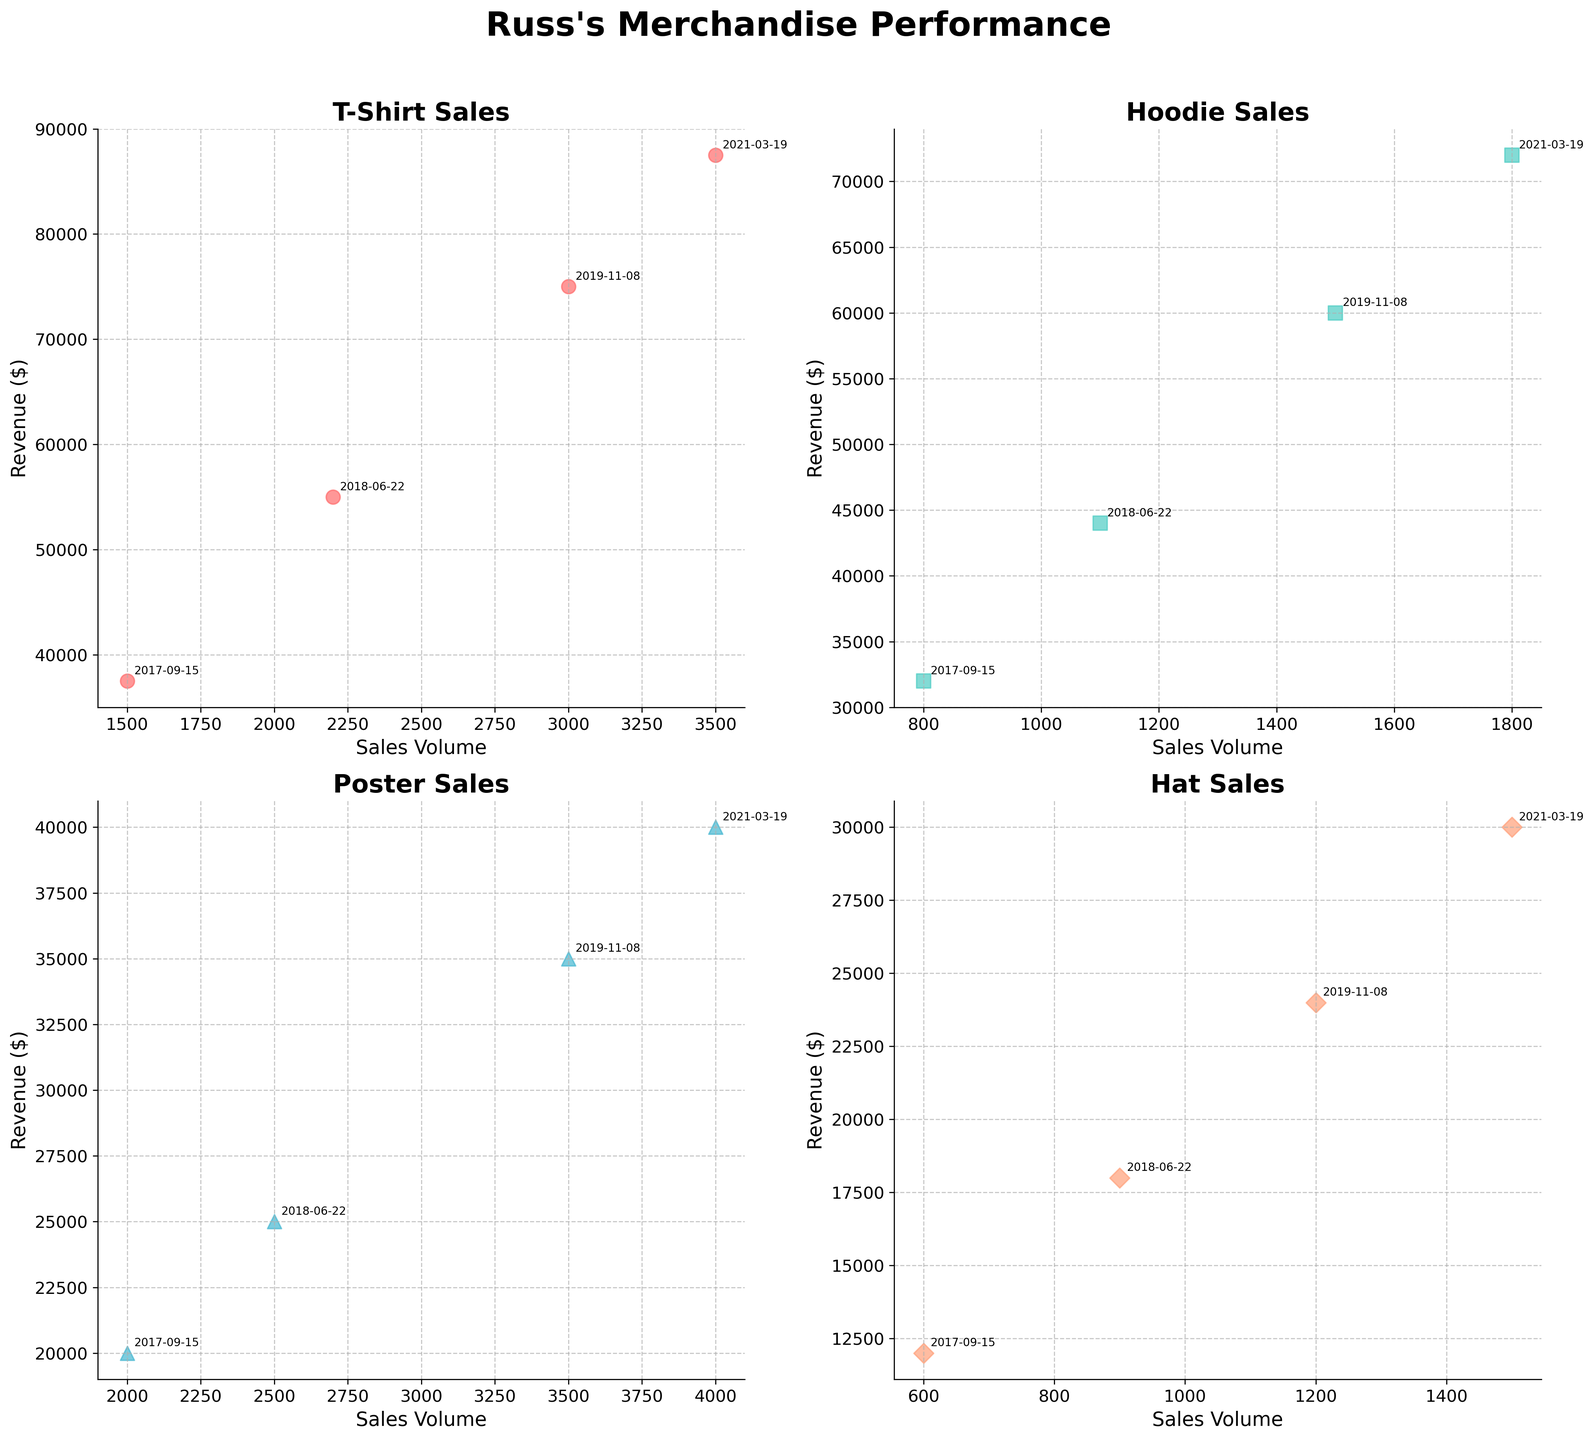What's the title of the figure? The title of the figure is located at the top and is readable directly.
Answer: Russ's Merchandise Performance Which product category has the highest sales volume on 2021-03-19? Look for the highest point on the x-axis in the subplot for 2021-03-19. The T-Shirt category has the highest sales volume on that date, as seen in the scatter plot for T-Shirt Sales.
Answer: T-Shirt How does the sales volume of Hoodies compare between 2017-09-15 and 2018-06-22? Check the Hoodies subplot and locate the sales volume points for the indicated dates. The sales volume for Hoodies is 800 on 2017-09-15 and 1100 on 2018-06-22.
Answer: 1100 is greater than 800 Which product consistently shows the highest revenue across all tour dates? Examine each subplot for the highest points on the y-axis across all dates. The T-Shirt category consistently shows the highest revenue on all tour dates.
Answer: T-Shirt What's the difference in revenue for Posters between 2018-06-22 and 2019-11-08? Locate the Posters subplot and identify the revenue points for the given dates. The revenue for Posters is 25000 on 2018-06-22 and 35000 on 2019-11-08. The difference is 35000 - 25000.
Answer: 10000 Which tour date has the lowest revenue for Hats? Find the Hat sales subplot and look at the y-axis points for different dates. The tour date with the lowest revenue (12000) for Hats is 2017-09-15.
Answer: 2017-09-15 What is the average sales volume of T-Shirts across all tour dates? Sum the sales volumes of T-Shirts from all tour dates, then divide by the number of dates. (1500 + 2200 + 3000 + 3500) / 4 = 10200 / 4.
Answer: 2550 Is there any correlation between sales volume and revenue for Posters, based on the scatter plot? Observe the trend in the Poster sales subplot. Higher sales volumes generally correspond to higher revenue points, indicating a positive correlation.
Answer: Yes How do the sales volumes of Hats in 2017 compare to 2021? Check the subplot for Hats and identify the sales volumes for 2017-09-15 and 2021-03-19. In 2017 it was 600, and in 2021 it was 1500.
Answer: 1500 is greater than 600 